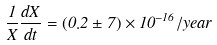<formula> <loc_0><loc_0><loc_500><loc_500>\frac { 1 } { X } \frac { d X } { d t } = ( 0 . 2 \pm 7 ) \times 1 0 ^ { - 1 6 } / y e a r</formula> 